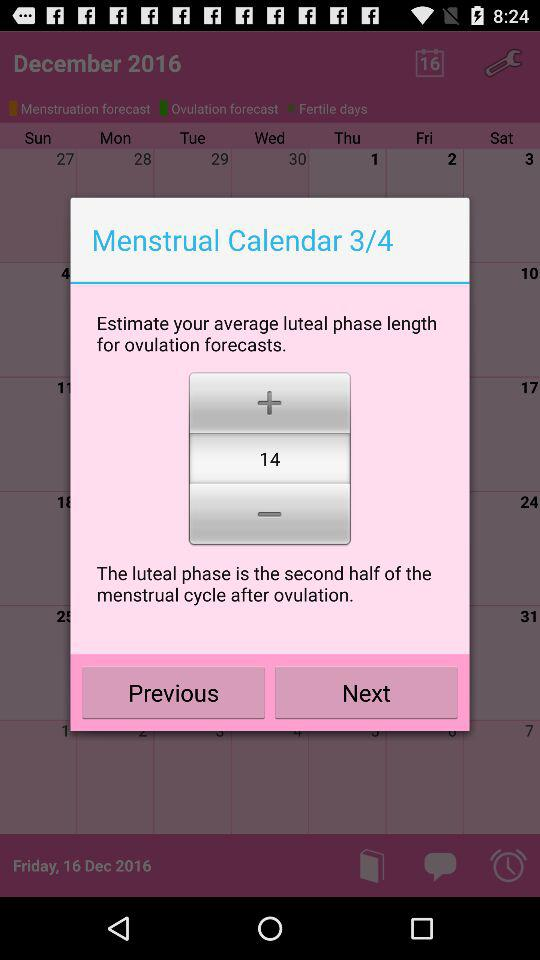How many pages are there in total? There are four pages in total. 